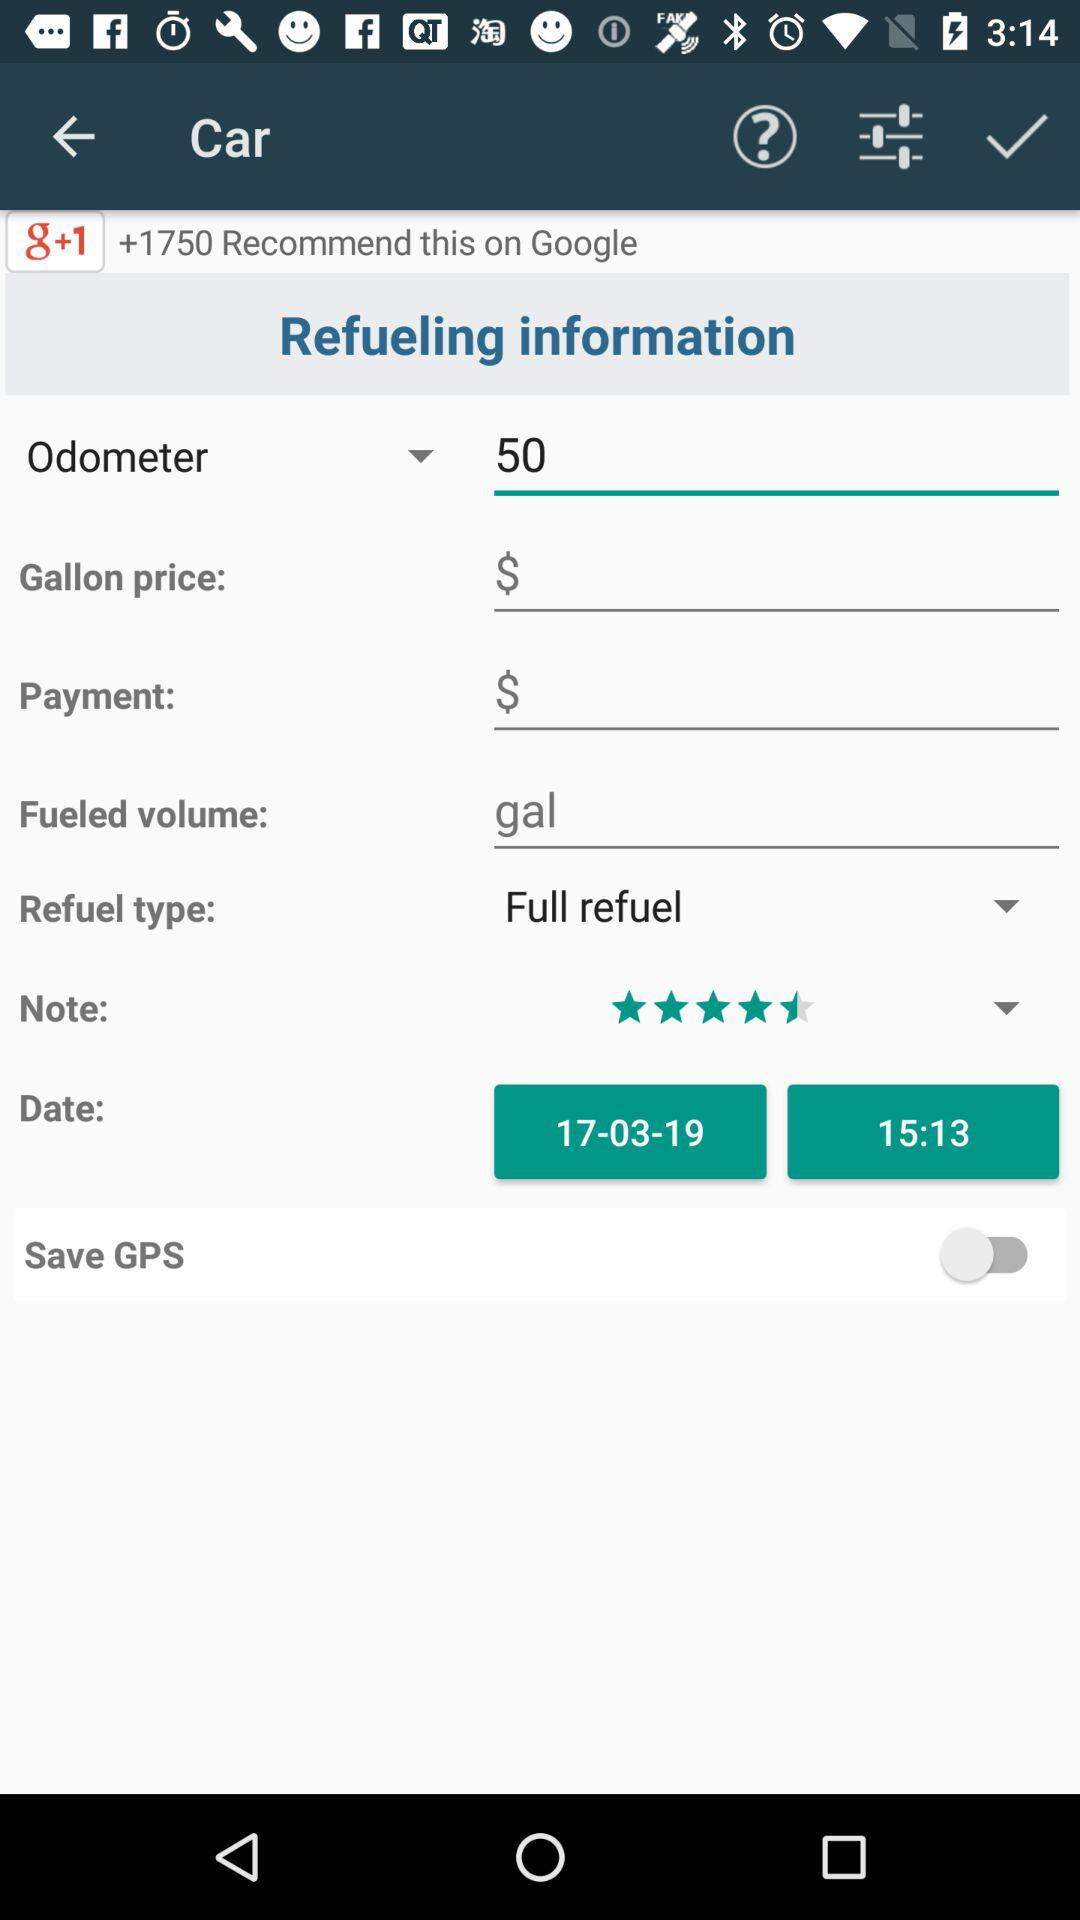What is the time? The time is 15:13. 